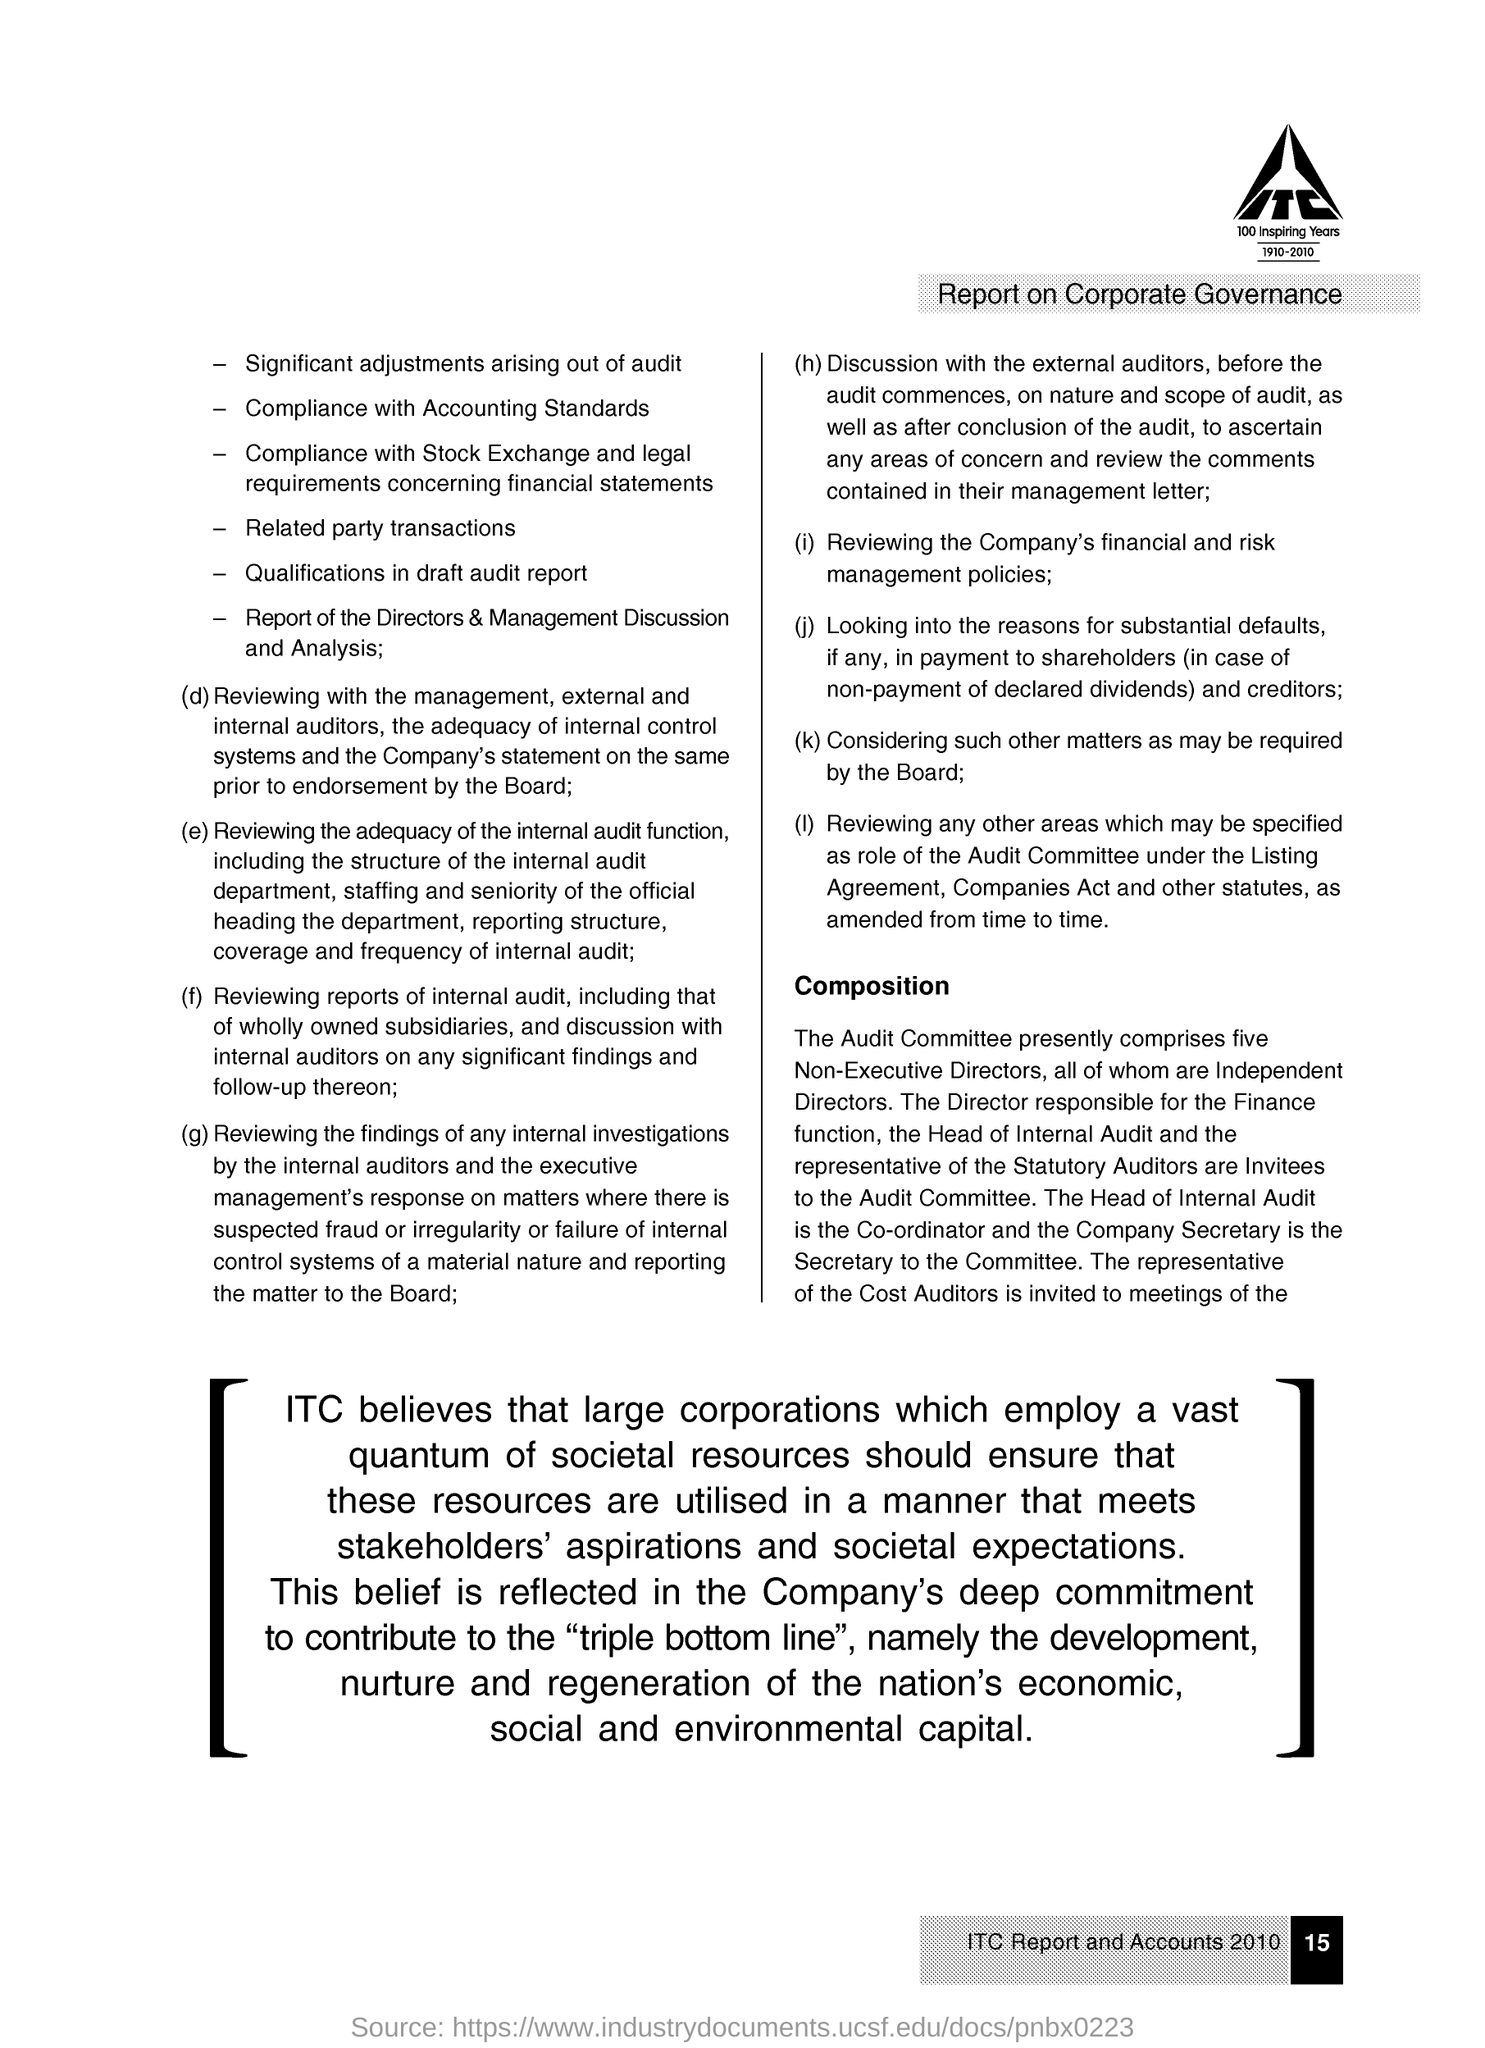How many Non-Executive Directors does the Audit Committee presently have?
Offer a terse response. Five. Who is the Head of Internal Audit?
Your response must be concise. The co-ordinator. Who is the Secretary to the Committee?
Keep it short and to the point. Company secretary. 